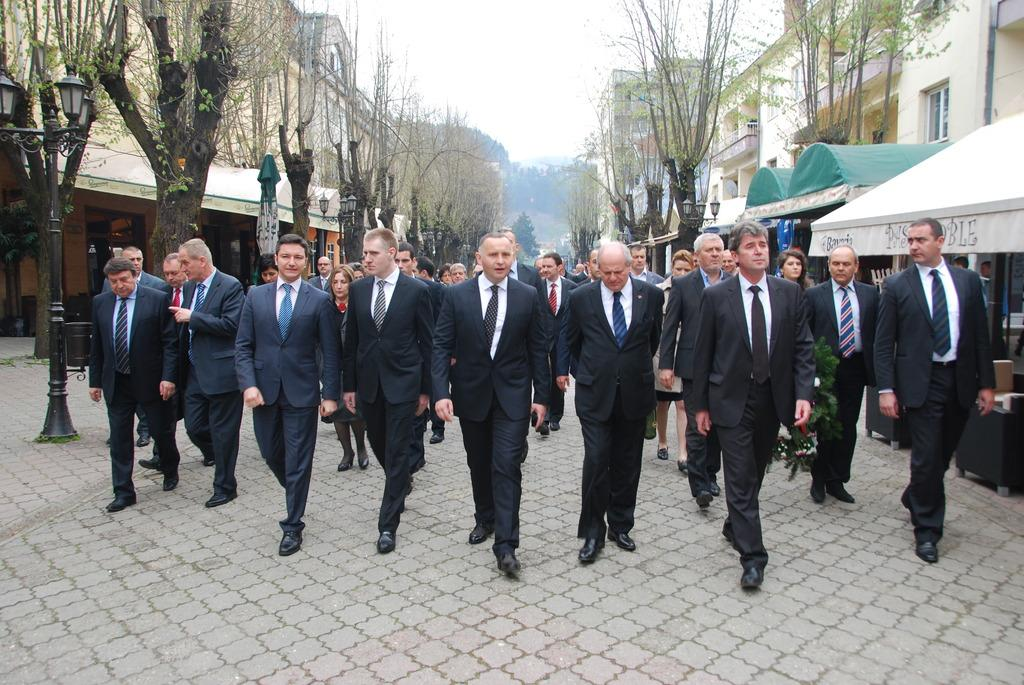What is the main focus of the image? The main focus of the image is the people in the center. What can be seen on the right side of the image? There are buildings on the right side of the image. What type of vegetation is on the left side of the image? There are trees on the left side of the image. How many heads of cabbage are visible in the image? There are no heads of cabbage present in the image. What type of animals can be seen grazing on the left side of the image? There are no animals visible in the image, only trees on the left side. 